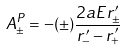Convert formula to latex. <formula><loc_0><loc_0><loc_500><loc_500>A _ { \pm } ^ { P } = - ( \pm ) \frac { 2 a E r ^ { \prime } _ { \pm } } { r _ { - } ^ { \prime } - r _ { + } ^ { \prime } }</formula> 